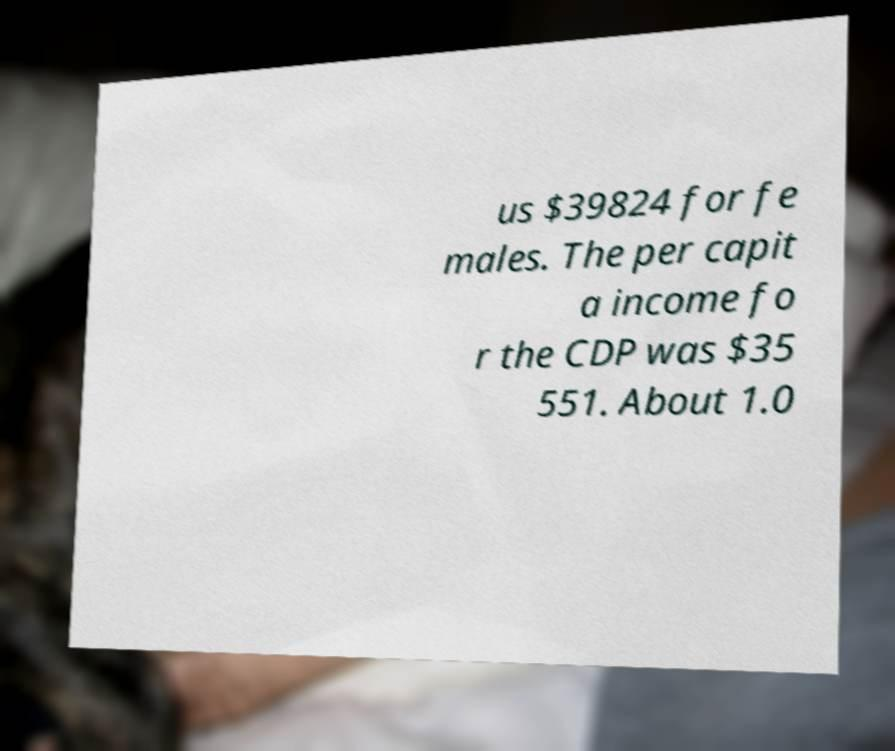I need the written content from this picture converted into text. Can you do that? us $39824 for fe males. The per capit a income fo r the CDP was $35 551. About 1.0 